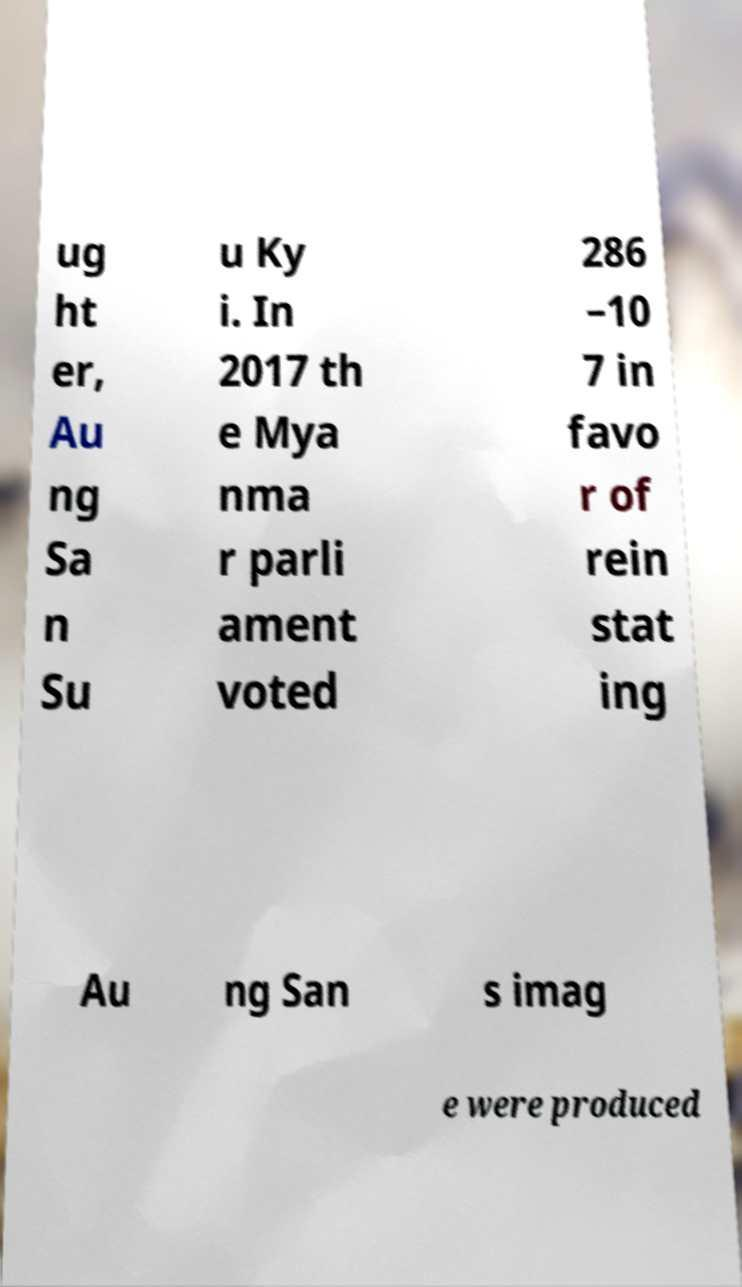There's text embedded in this image that I need extracted. Can you transcribe it verbatim? ug ht er, Au ng Sa n Su u Ky i. In 2017 th e Mya nma r parli ament voted 286 –10 7 in favo r of rein stat ing Au ng San s imag e were produced 